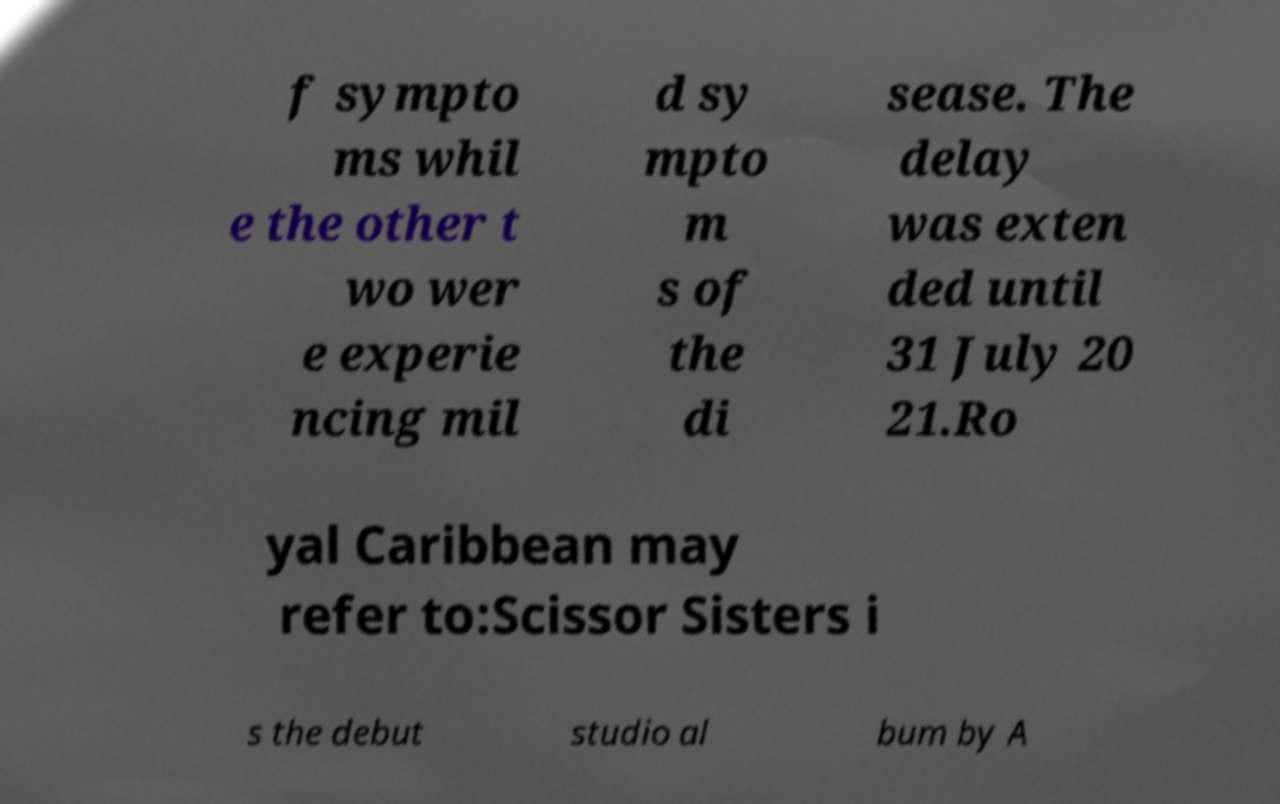What messages or text are displayed in this image? I need them in a readable, typed format. f sympto ms whil e the other t wo wer e experie ncing mil d sy mpto m s of the di sease. The delay was exten ded until 31 July 20 21.Ro yal Caribbean may refer to:Scissor Sisters i s the debut studio al bum by A 